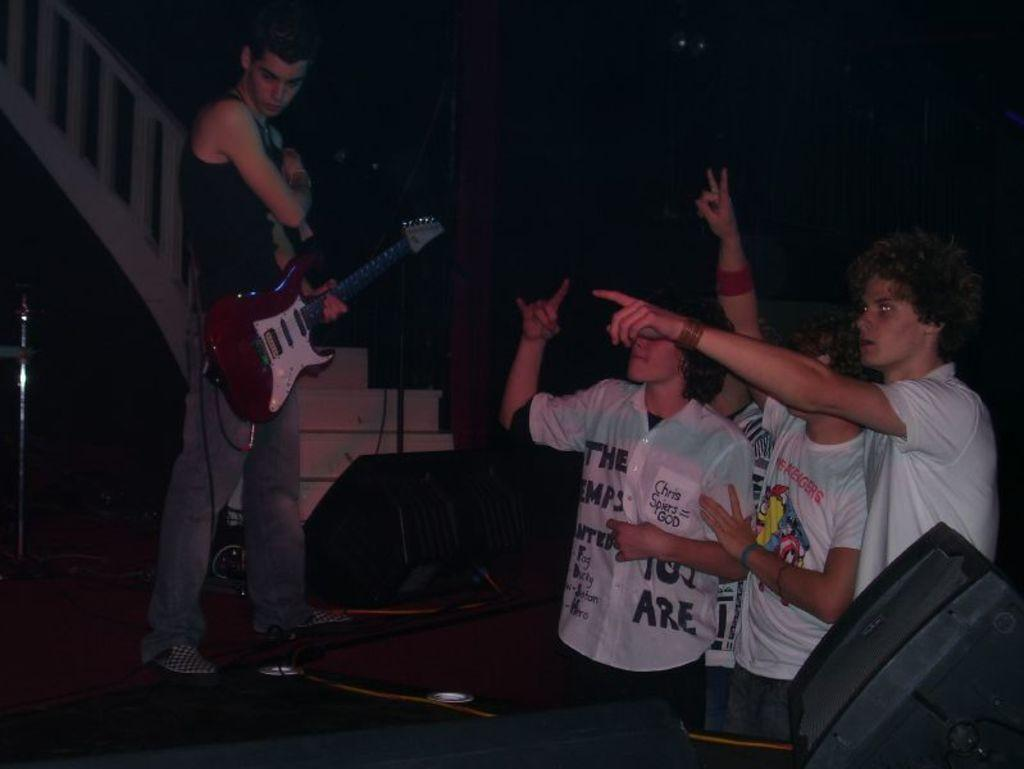Who is present in the image? There is a person in the image. What is the person holding? The person is holding a guitar. What can be seen behind the person? There is a staircase behind the person. How many people are on the right side of the image? There are three people on the right side of the image. What type of decision can be seen being made by the rat in the image? There is no rat present in the image, so it is not possible to determine what decision might be made by a rat. 